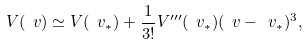Convert formula to latex. <formula><loc_0><loc_0><loc_500><loc_500>V ( \ v ) \simeq V ( \ v _ { * } ) + \frac { 1 } { 3 ! } V ^ { \prime \prime \prime } ( \ v _ { * } ) ( \ v - \ v _ { * } ) ^ { 3 } ,</formula> 